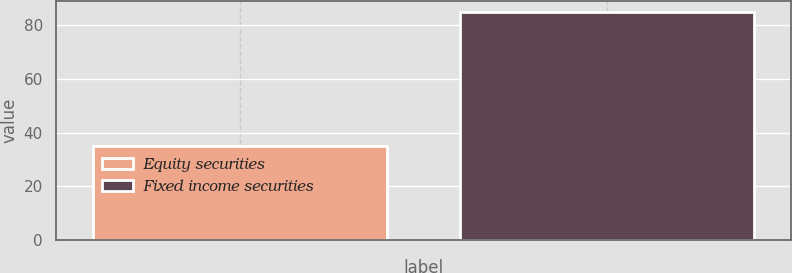Convert chart. <chart><loc_0><loc_0><loc_500><loc_500><bar_chart><fcel>Equity securities<fcel>Fixed income securities<nl><fcel>35<fcel>85<nl></chart> 